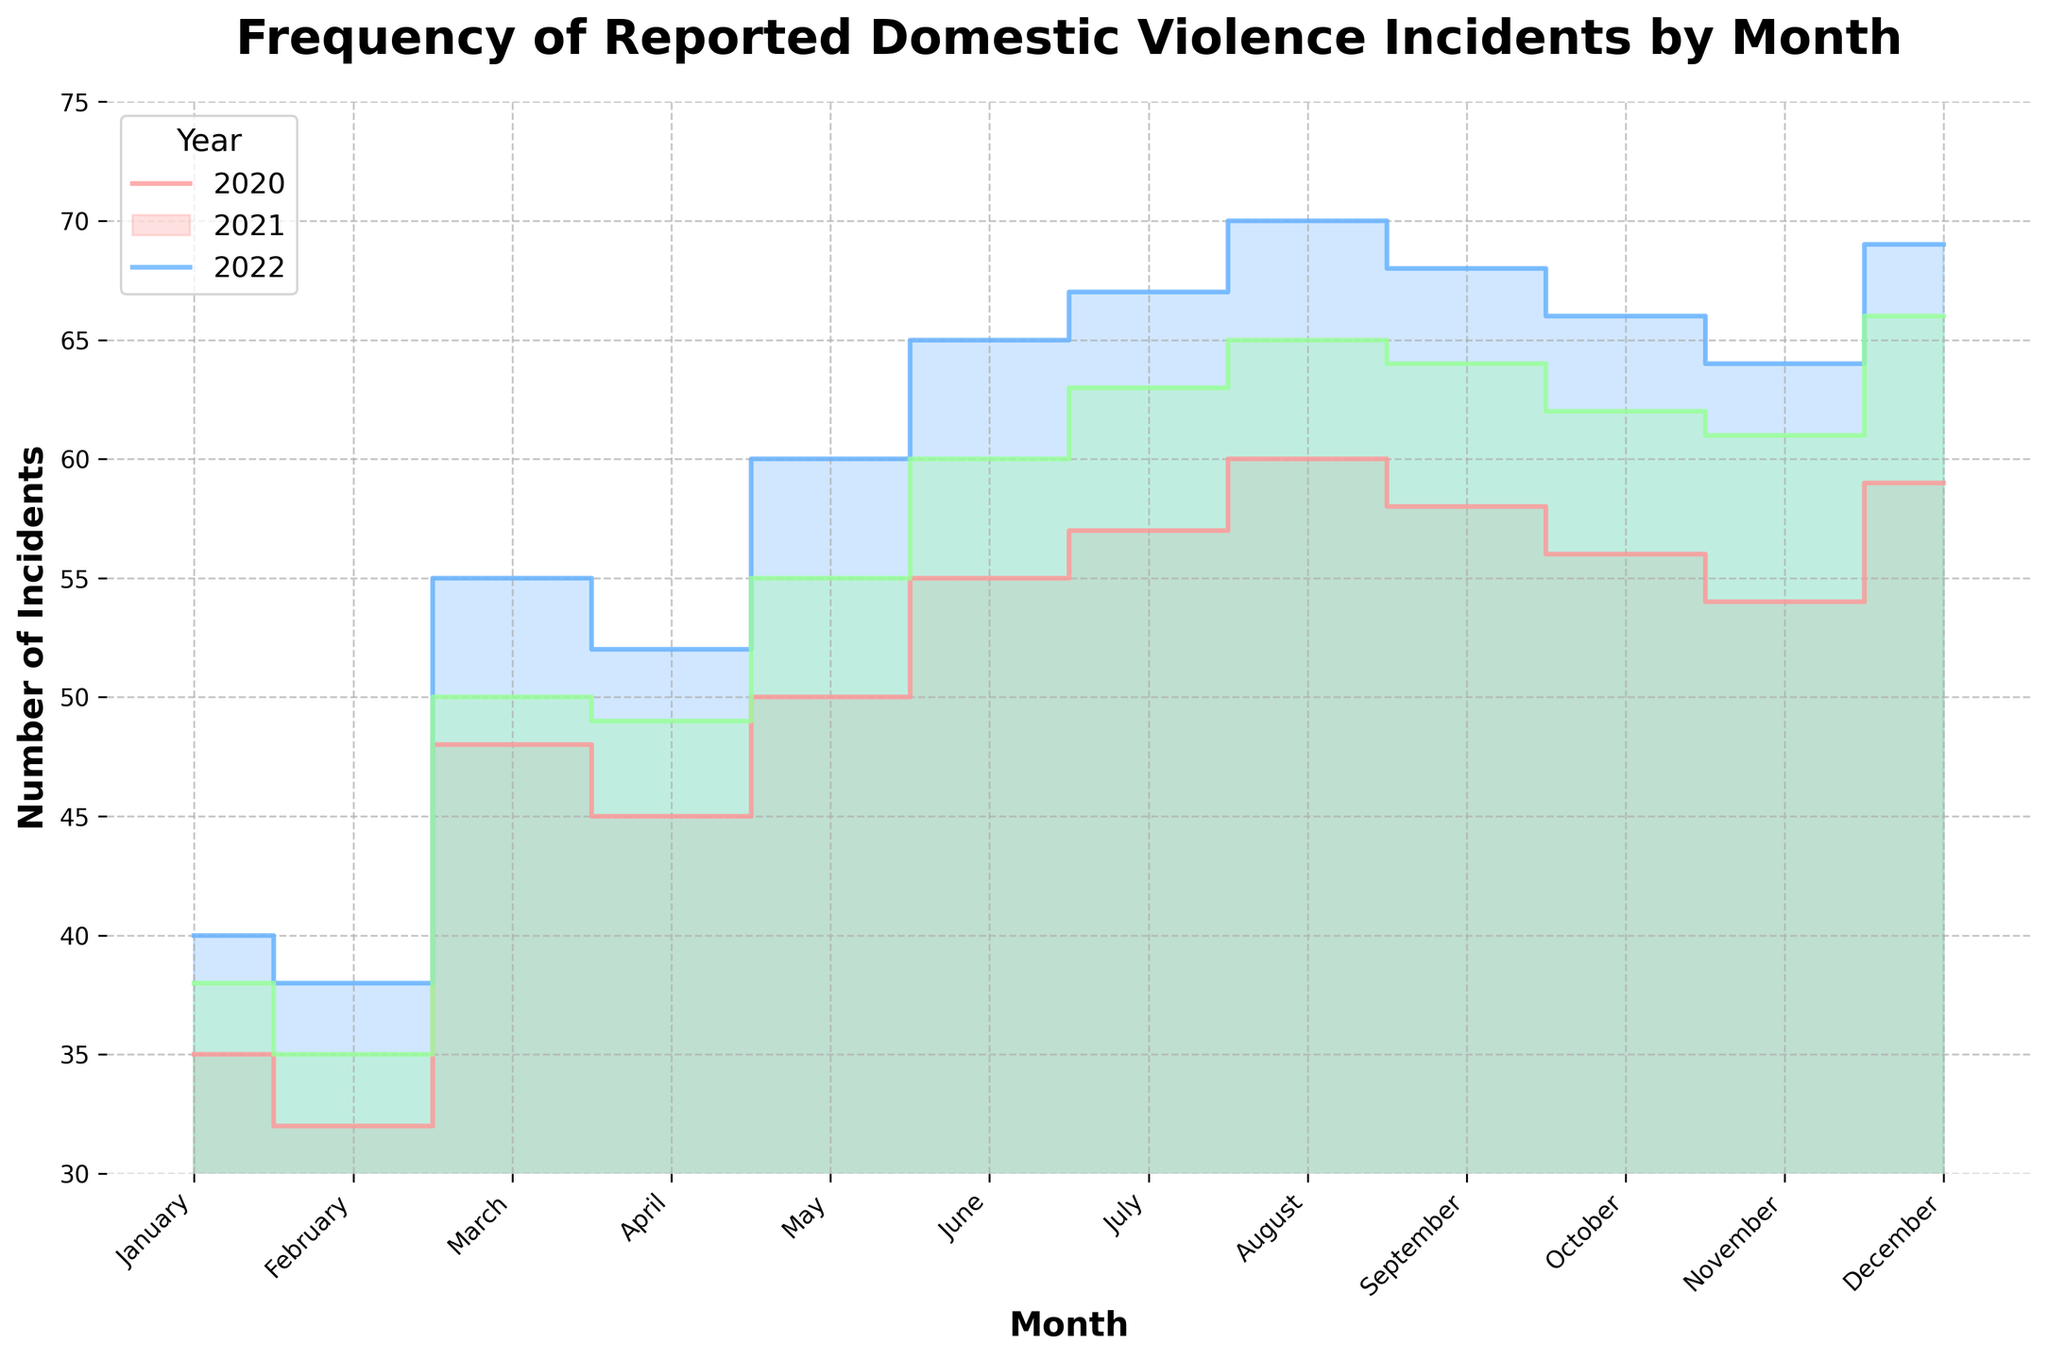What's the title of the figure? The title of the figure is typically placed at the top. In this case, it reads "Frequency of Reported Domestic Violence Incidents by Month".
Answer: Frequency of Reported Domestic Violence Incidents by Month How many years of data are represented in the chart? The legend and data lines use different colors for each year. The legend shows three entries: "2020", "2021", and "2022".
Answer: Three Which month had the highest increase in reported incidents from 2020 to 2021? By examining the differences between the lines for 2020 and 2021, May shows an increase from 50 incidents to 60 incidents, which is a 10-incident increase.
Answer: May What color represents the year 2021? The legend clarifies which colors correspond to the years. The year 2021 is represented by the second color, which is a shade of blue.
Answer: Blue In which month of 2022 were the most incidents reported? By looking at the green line for 2022 and noting the highest point, it is clear in August with 65 incidents.
Answer: August Calculate the average number of reported incidents for the year 2020. To find the average, sum the incidents reported each month in 2020 and divide by 12. (35+32+48+45+50+55+57+60+58+56+54+59) / 12 = 609 / 12
Answer: 50.75 Which year consistently had the lowest number of reported incidents each month? By comparing the lines month by month, the 2020 line consistently lies below the 2021 and 2022 lines.
Answer: 2020 What's the total number of reported incidents in July over the three years? To find the total, sum the reported incidents for July in 2020, 2021, and 2022: 57 + 67 + 63 = 187
Answer: 187 How does the trend of reported incidents differ between the years during the summer months (June - August)? During the summer months, 2020 sees a gradual rise, while both 2021 and 2022 also show increasing trends, though 2021 has higher peaks and rates of increase compared to 2020 and 2022.
Answer: 2021 increases the most during summer Which month shows the greatest variation in reported incidents across the three years? By comparing the differences vertically across all months, December shows a broad range from 59 incidents in 2020 to 69 in 2021 and 66 in 2022.
Answer: December 